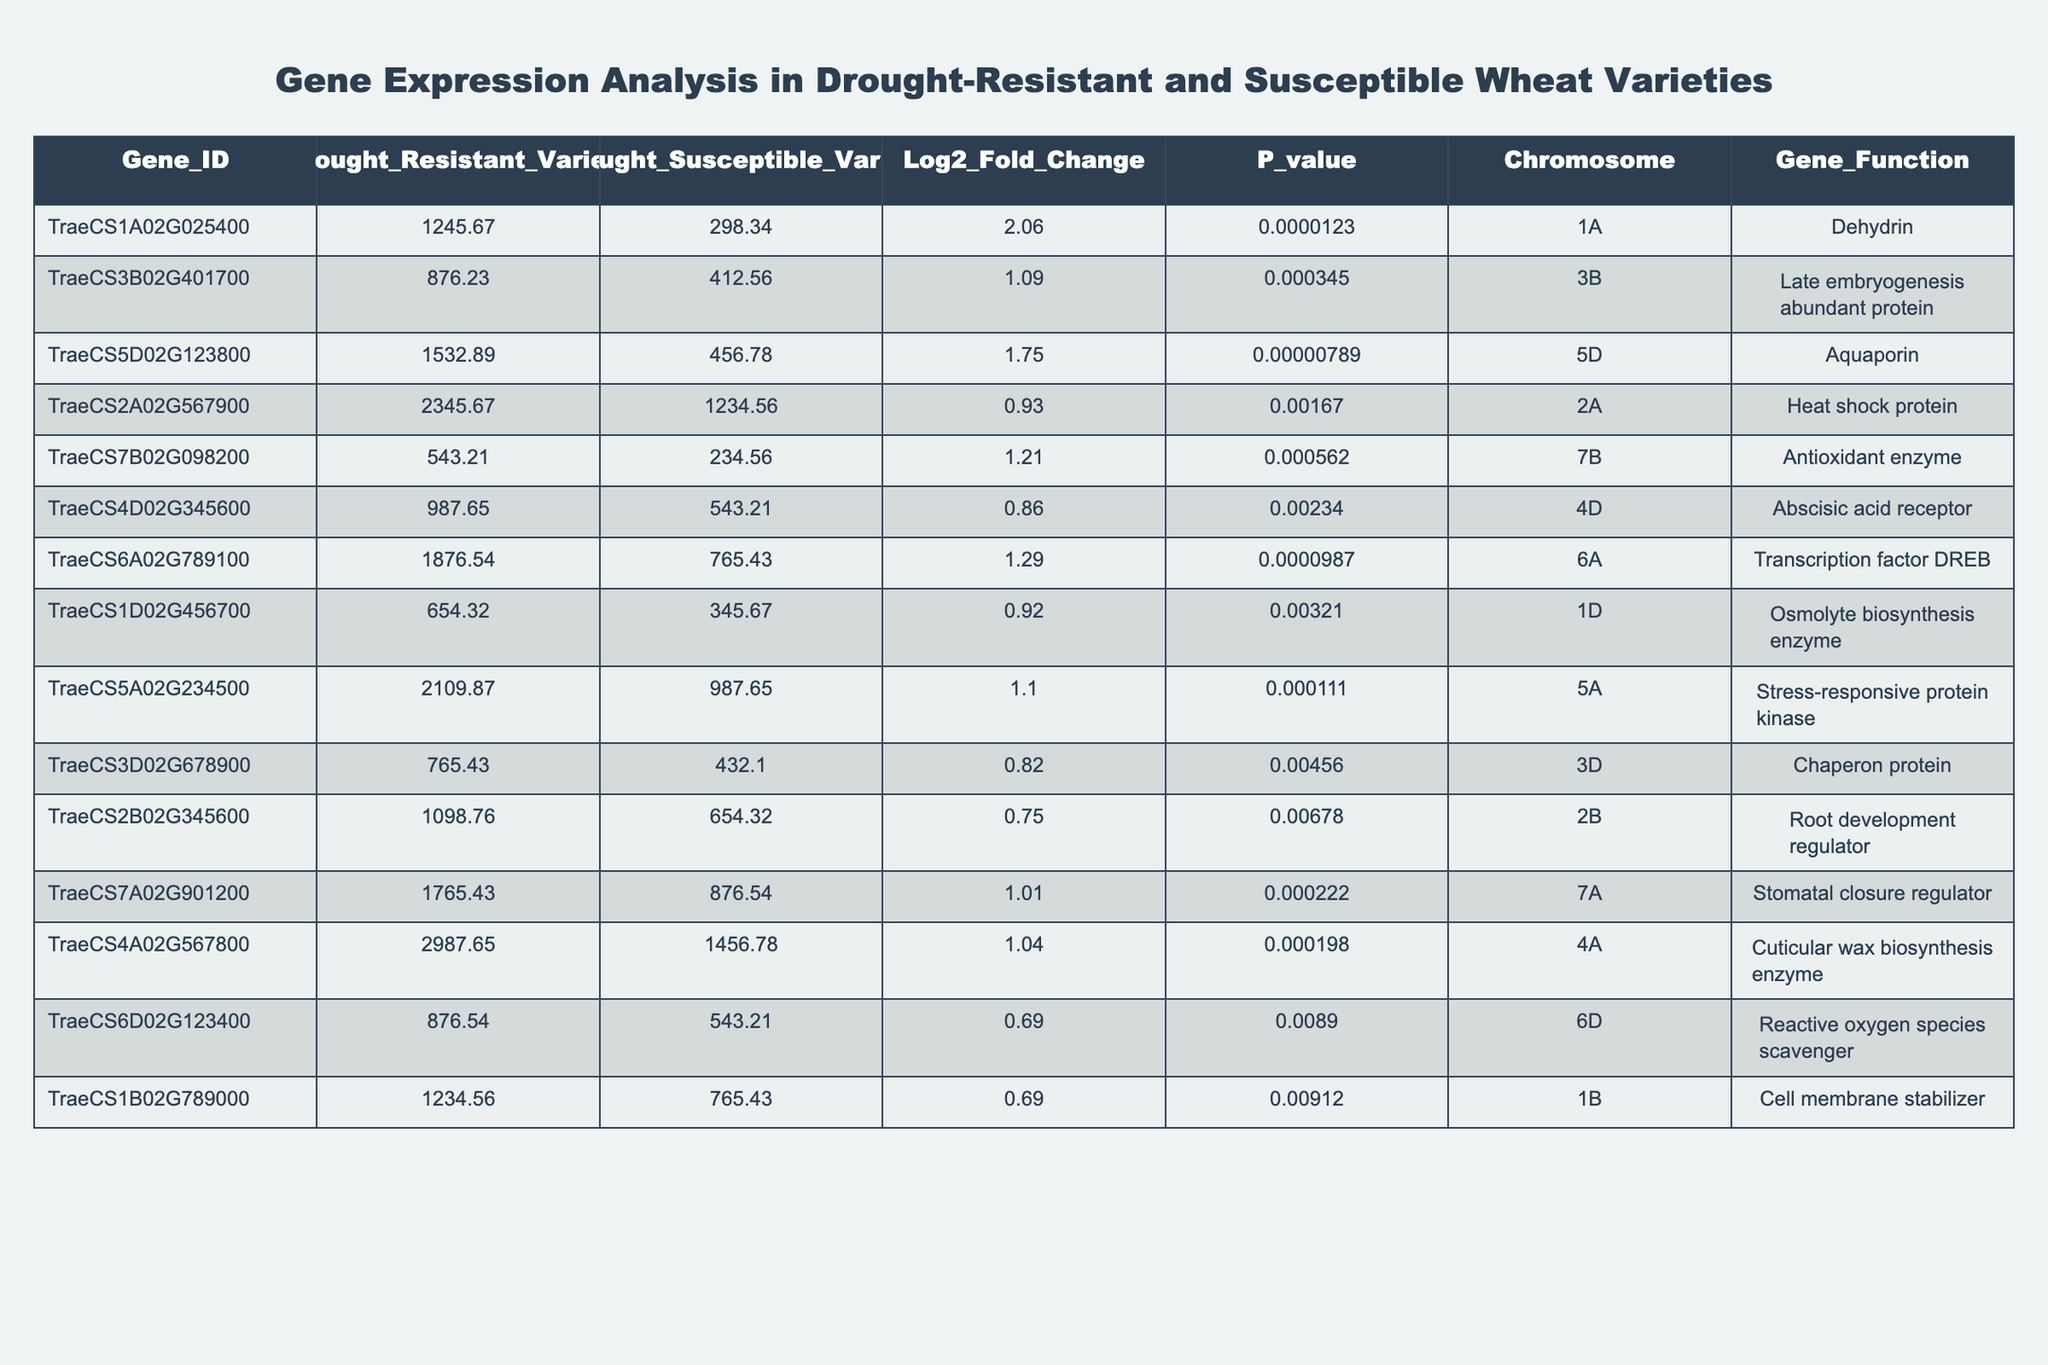What is the gene function of the gene with ID TraeCS1A02G025400? By looking at the table, the gene function corresponding to the ID TraeCS1A02G025400 is listed under the "Gene_Function" column.
Answer: Dehydrin Which gene has the highest expression level in the drought-resistant variety? The highest expression level in the drought-resistant variety can be identified by comparing the values in the "Drought_Resistant_Variety" column, and the gene TraeCS4A02G567800 has the highest value of 2987.65.
Answer: TraeCS4A02G567800 What is the p-value of the gene TraeCS5D02G123800? The p-value for the gene TraeCS5D02G123800 is listed in the table's "P_value" column, which shows a value of 7.89e-06.
Answer: 7.89e-06 Is there any gene with a Log2_Fold_Change greater than 1.5? By examining the "Log2_Fold_Change" column, the gene TraeCS1A02G025400 has a value of 2.06, which is greater than 1.5.
Answer: Yes What is the difference in expression levels of TraeCS7B02G098200 between drought-resistant and susceptible varieties? To find the difference, subtract the expression level in the drought-susceptible variety (234.56) from that in the drought-resistant variety (543.21): 543.21 - 234.56 = 308.65.
Answer: 308.65 What is the average Log2_Fold_Change for all genes listed? First, sum the Log2_Fold_Change values: (2.06 + 1.09 + 1.75 + 0.93 + 1.21 + 0.86 + 1.29 + 0.92 + 1.10 + 0.82 + 0.75 + 1.01 + 1.04 + 0.69 + 0.69) = 13.06, then divide by the total number of genes (15): 13.06 / 15 = 0.87.
Answer: 0.87 Which chromosome has the gene with the lowest p-value? The gene with the lowest p-value is TraeCS1A02G025400 with a p-value of 1.23e-05, which is found on chromosome 1A.
Answer: 1A How many genes have a p-value less than 0.001? Counting all the p-values less than 0.001 from the "P_value" column, we find that 6 genes meet this criterion.
Answer: 6 What is the total expression level of drought-resistant varieties for genes located on chromosome 3? Summing the drought-resistant expression levels for genes on chromosome 3: TraeCS3B02G401700 (876.23) + TraeCS3D02G678900 (765.43) = 1641.66.
Answer: 1641.66 Is there a gene that has both high expression in drought-resistant variety and a Low p-value? TraeCS5D02G123800 has a high expression level (1532.89) in drought-resistant varieties and a very low p-value (7.89e-06), confirming that such a gene exists.
Answer: Yes 